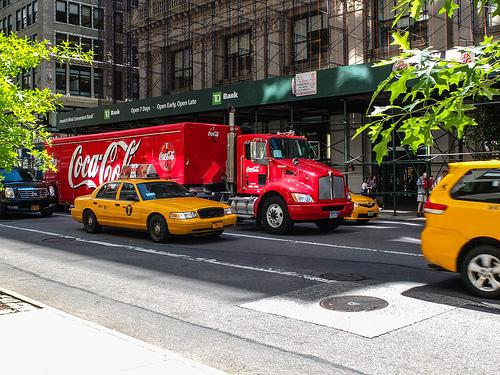Are there any advertisements in the image? Describe them. There is an advertisement on top of a taxi cab, and a long green sign on the TD Bank building with the word "bank" visible. Count the number of pedestrians standing on the sidewalk in the image. There are three pedestrians standing on the sidewalk. Describe the setting of the image, including any notable objects or areas around the vehicles. The image features a street setting with vehicles on the road, a building in the distance, a tree with green leaves, and pedestrians on the sidewalk. What is the primary mode of transportation depicted in the image? Yellow taxis and red truck are the primary modes of transportation depicted in the image. Based on the objects’ interactions, describe the traffic situation in the image. The traffic situation seems to be in motion, with a red truck next to a taxi cab, a black SUV following the taxi, and some yellow taxis in the middle lane of traffic. Identify the color and the primary focus of some vehicles present in the image. There is a red Coca Cola truck, a black SUV, and multiple yellow taxis in the image. Can you identify any potential road hazards in the image? There could be potential road hazards like a pothole on the ground and a faded white line on the street. Analyze the sentiment of the image. The image represents a busy city scene with various vehicles, pedestrians, and some vegetation. Name at least two objects visible on the street in this image and describe their position. A black manhole next to a taxi cab and two round manholes in the middle of the street are visible. 